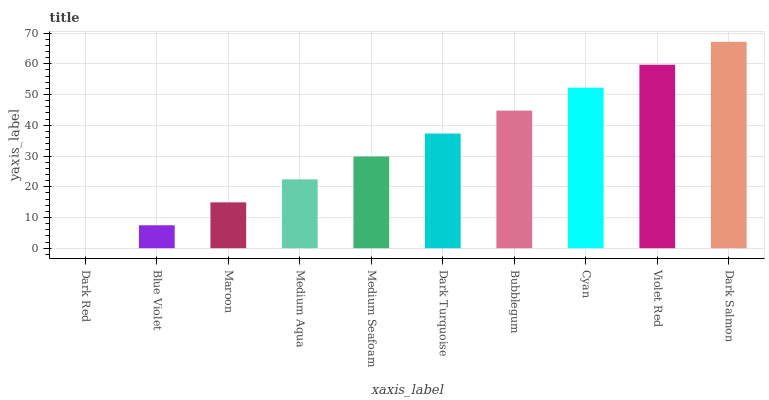Is Dark Red the minimum?
Answer yes or no. Yes. Is Dark Salmon the maximum?
Answer yes or no. Yes. Is Blue Violet the minimum?
Answer yes or no. No. Is Blue Violet the maximum?
Answer yes or no. No. Is Blue Violet greater than Dark Red?
Answer yes or no. Yes. Is Dark Red less than Blue Violet?
Answer yes or no. Yes. Is Dark Red greater than Blue Violet?
Answer yes or no. No. Is Blue Violet less than Dark Red?
Answer yes or no. No. Is Dark Turquoise the high median?
Answer yes or no. Yes. Is Medium Seafoam the low median?
Answer yes or no. Yes. Is Bubblegum the high median?
Answer yes or no. No. Is Dark Red the low median?
Answer yes or no. No. 